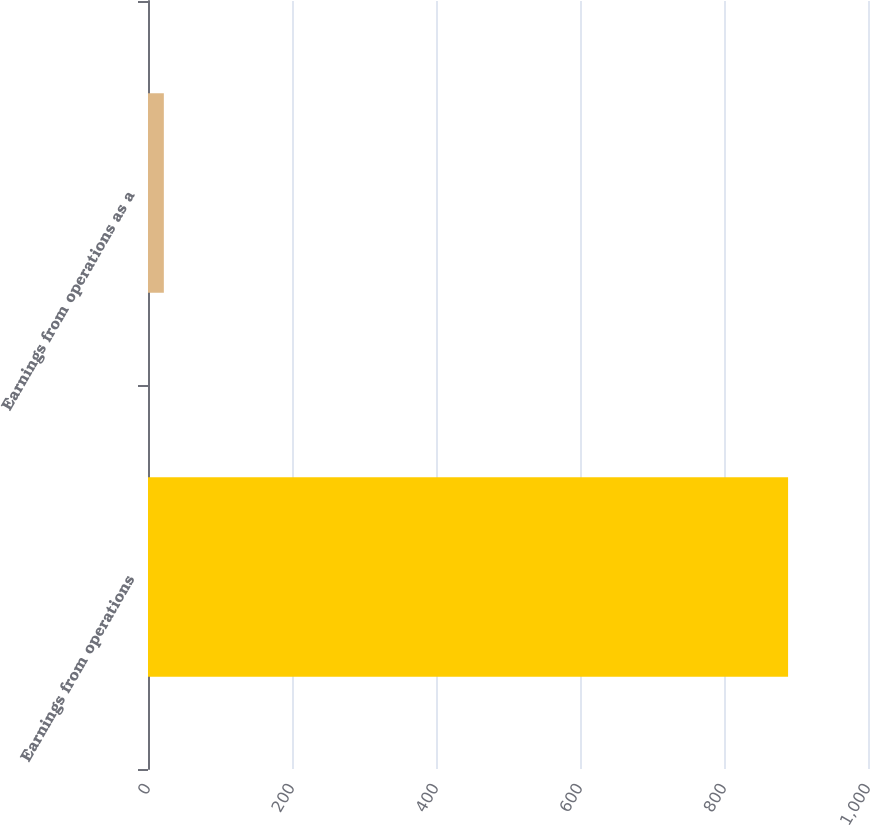<chart> <loc_0><loc_0><loc_500><loc_500><bar_chart><fcel>Earnings from operations<fcel>Earnings from operations as a<nl><fcel>889<fcel>22<nl></chart> 